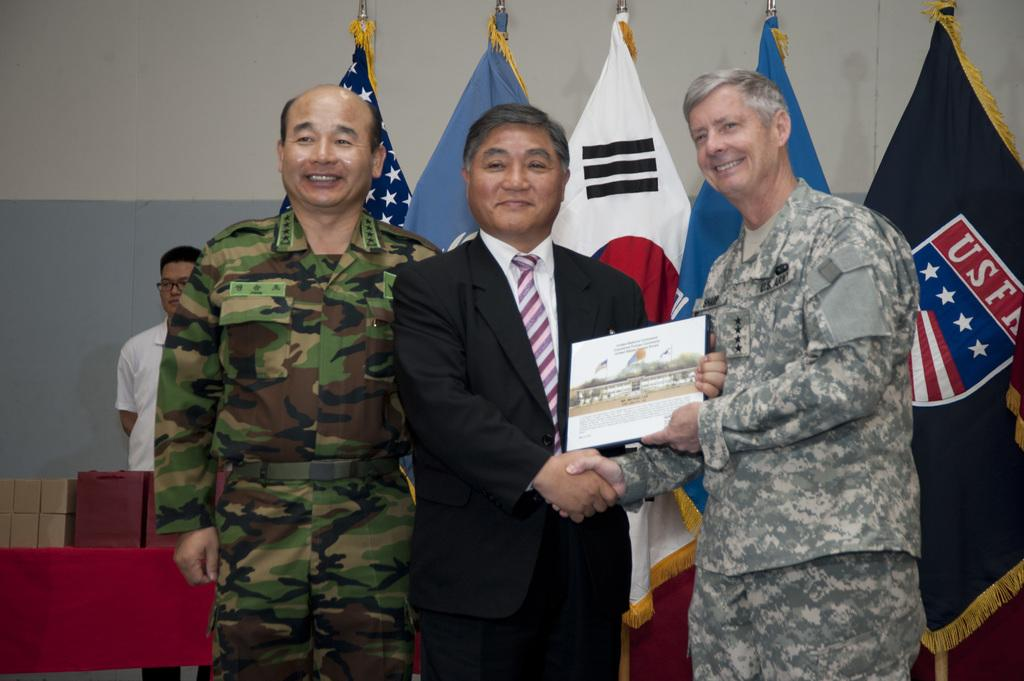How many people are in the image? There are four men standing in the image. What are two of the men doing in the image? Two of the men are holding an object. What can be seen in the background of the image? There are flags and a wall visible in the background of the image. Are there any other objects present in the background of the image? Yes, there are other unspecified objects in the background of the image. What type of seed is being planted by the committee in the image? There is no committee or seed present in the image. Is there a river visible in the image? No, there is no river visible in the image. 